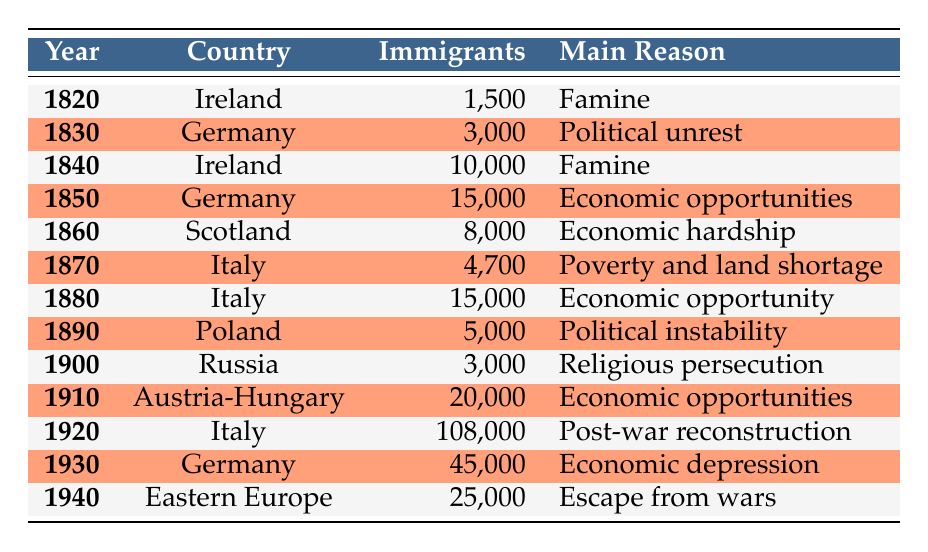What was the main reason for migration from Ireland in 1840? The table lists the main reason for migration from Ireland in 1840 as "Famine."
Answer: Famine Which country had the highest number of immigrants in 1920? According to the table, Italy had the highest number of immigrants in 1920, with 108,000 individuals.
Answer: Italy Was there an increase in the number of German immigrants from 1830 to 1930? The table shows German immigrants were 3,000 in 1830 and 45,000 in 1930, indicating an increase.
Answer: Yes What was the total number of immigrants from Italy in the years mentioned (1870, 1880, and 1920)? The table shows 4,700 in 1870, 15,000 in 1880, and 108,000 in 1920. Summing these gives 4,700 + 15,000 + 108,000 = 127,700.
Answer: 127,700 How many immigrants came from Austria-Hungary in 1910? The table indicates that Austria-Hungary had 20,000 immigrants in 1910.
Answer: 20,000 During which decade did economic opportunities seem to be the main reason for migration from Germany? The table lists economic opportunities as the main reason in the years 1850 and 1930, both decades are part of the 19th and 20th centuries.
Answer: 1850s and 1930s What percentage of the total immigrants recorded in the table came from Italy? The total number of immigrants in the table is 232,000. The total from Italy is 127,700. To find the percentage, (127,700 / 232,000) * 100 = 55%.
Answer: 55% Was the reason for migration from Poland primarily due to political instability? The table shows political instability as the main reason for migration from Poland in 1890, confirming this as true.
Answer: Yes If you combine the number of immigrants from Ireland in 1820 and 1840, how many were there in total? The table records 1,500 immigrants from Ireland in 1820 and 10,000 immigrants in 1840. Adding these gives 1,500 + 10,000 = 11,500.
Answer: 11,500 